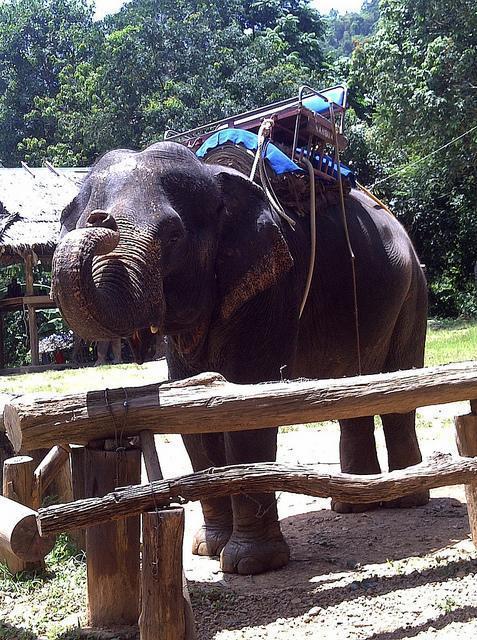How many people are pulling luggage?
Give a very brief answer. 0. 